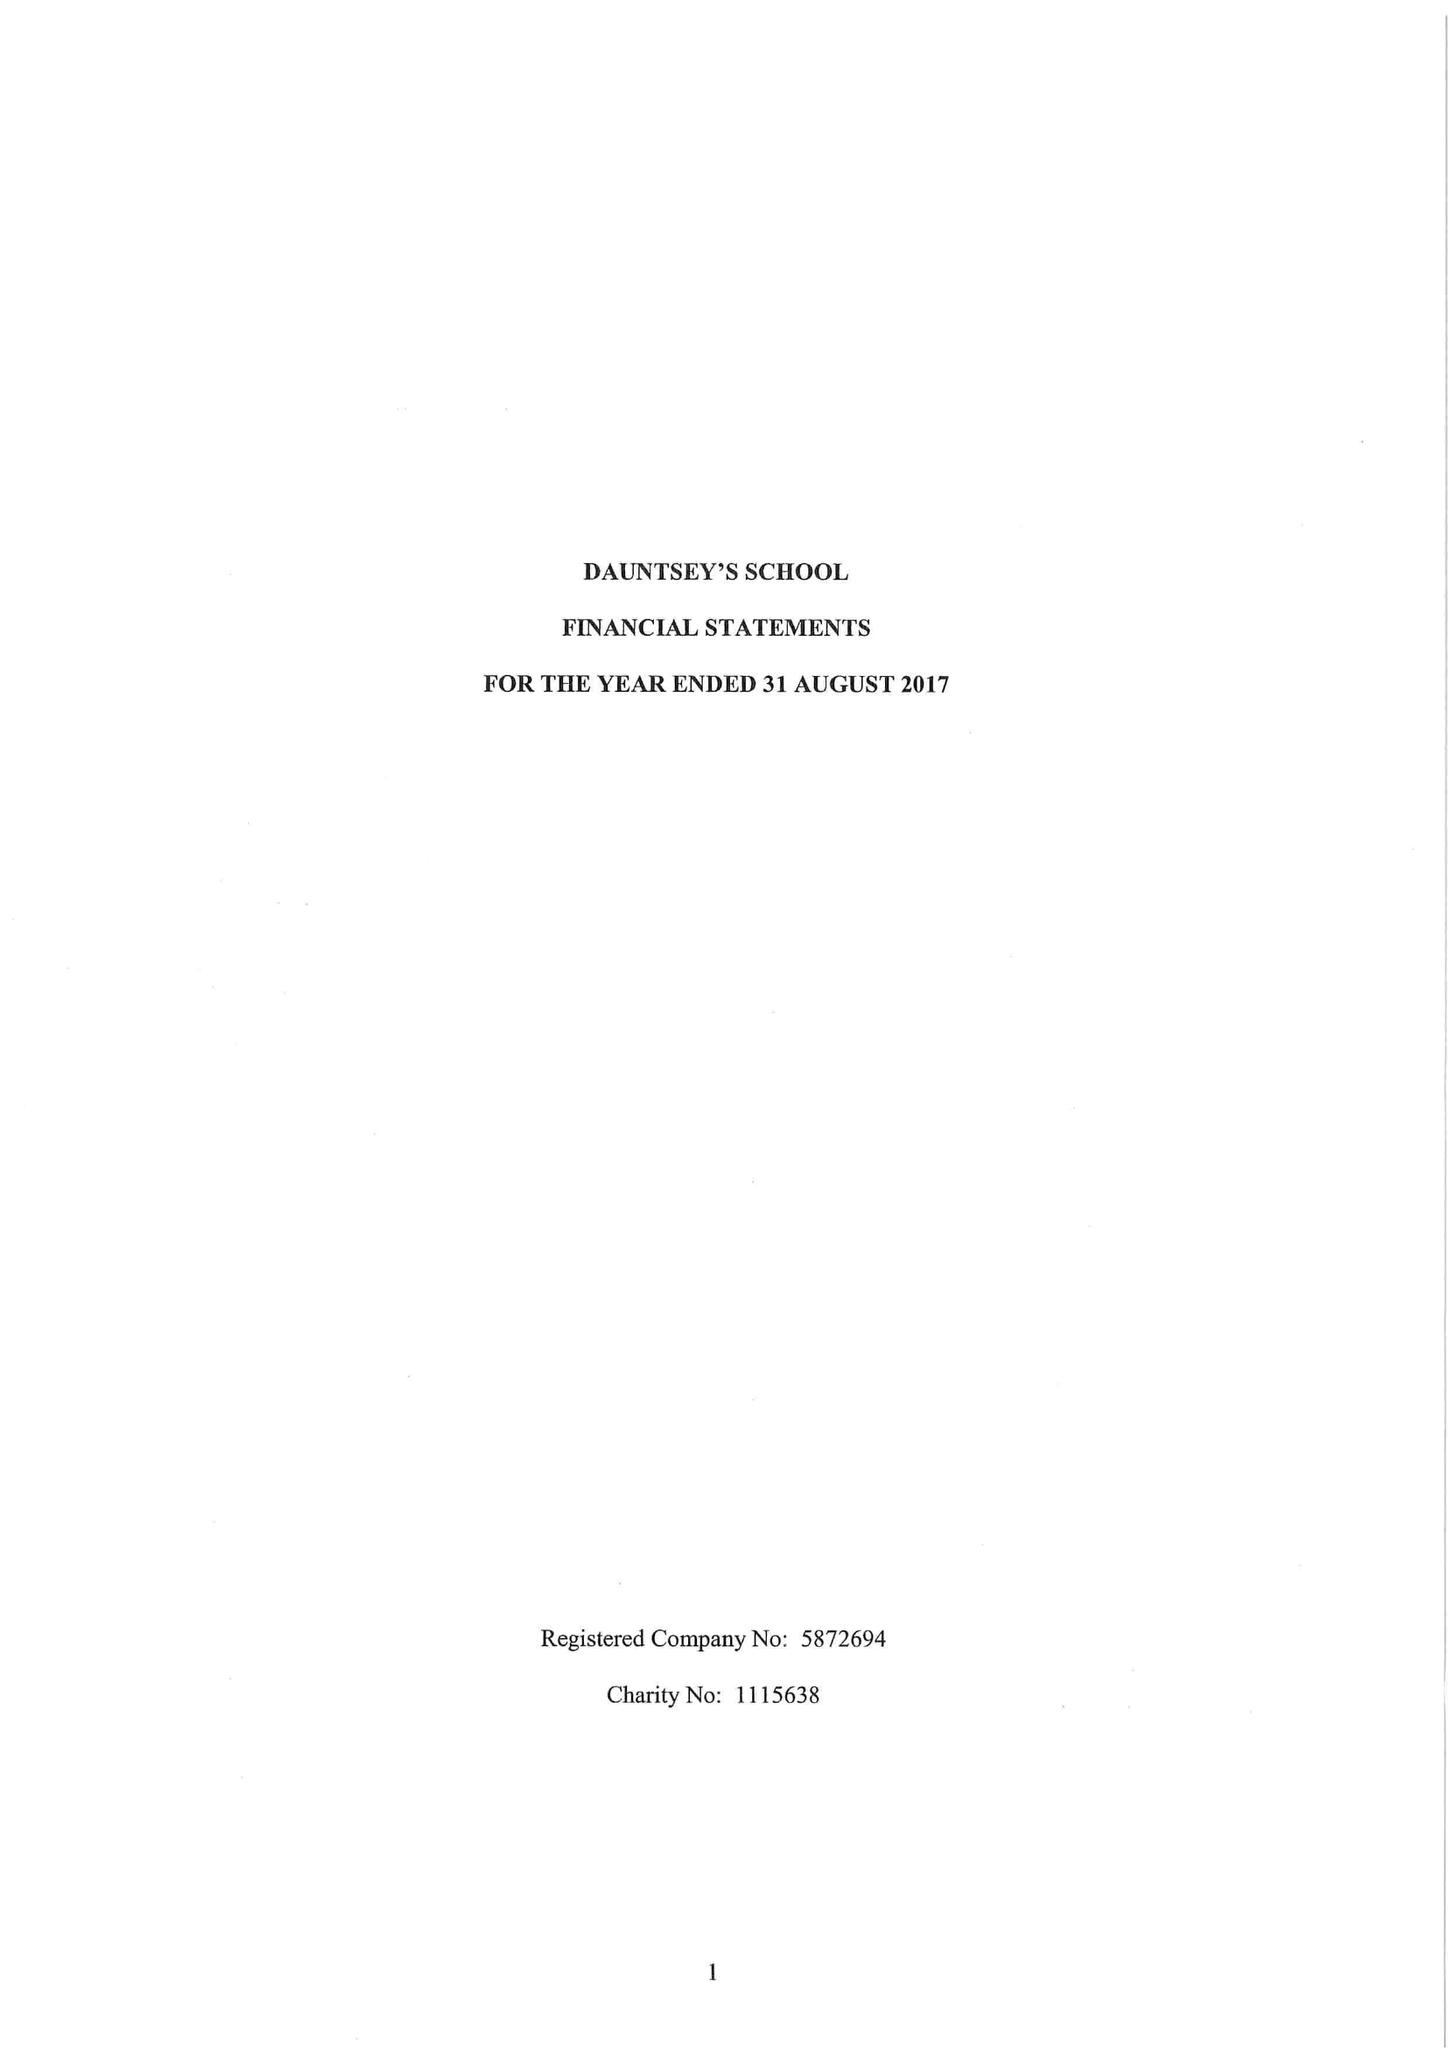What is the value for the address__postcode?
Answer the question using a single word or phrase. SN10 4HE 